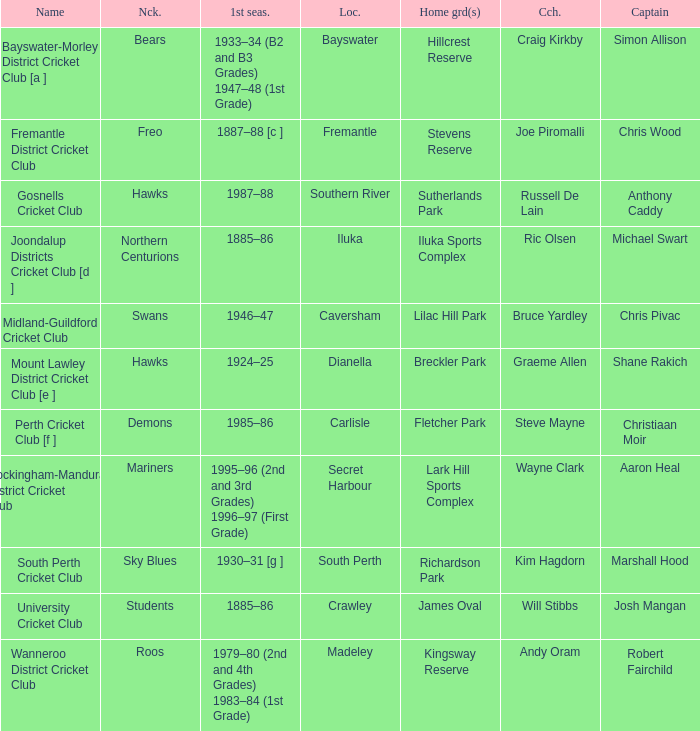What is the code nickname where Steve Mayne is the coach? Demons. Can you parse all the data within this table? {'header': ['Name', 'Nck.', '1st seas.', 'Loc.', 'Home grd(s)', 'Cch.', 'Captain'], 'rows': [['Bayswater-Morley District Cricket Club [a ]', 'Bears', '1933–34 (B2 and B3 Grades) 1947–48 (1st Grade)', 'Bayswater', 'Hillcrest Reserve', 'Craig Kirkby', 'Simon Allison'], ['Fremantle District Cricket Club', 'Freo', '1887–88 [c ]', 'Fremantle', 'Stevens Reserve', 'Joe Piromalli', 'Chris Wood'], ['Gosnells Cricket Club', 'Hawks', '1987–88', 'Southern River', 'Sutherlands Park', 'Russell De Lain', 'Anthony Caddy'], ['Joondalup Districts Cricket Club [d ]', 'Northern Centurions', '1885–86', 'Iluka', 'Iluka Sports Complex', 'Ric Olsen', 'Michael Swart'], ['Midland-Guildford Cricket Club', 'Swans', '1946–47', 'Caversham', 'Lilac Hill Park', 'Bruce Yardley', 'Chris Pivac'], ['Mount Lawley District Cricket Club [e ]', 'Hawks', '1924–25', 'Dianella', 'Breckler Park', 'Graeme Allen', 'Shane Rakich'], ['Perth Cricket Club [f ]', 'Demons', '1985–86', 'Carlisle', 'Fletcher Park', 'Steve Mayne', 'Christiaan Moir'], ['Rockingham-Mandurah District Cricket Club', 'Mariners', '1995–96 (2nd and 3rd Grades) 1996–97 (First Grade)', 'Secret Harbour', 'Lark Hill Sports Complex', 'Wayne Clark', 'Aaron Heal'], ['South Perth Cricket Club', 'Sky Blues', '1930–31 [g ]', 'South Perth', 'Richardson Park', 'Kim Hagdorn', 'Marshall Hood'], ['University Cricket Club', 'Students', '1885–86', 'Crawley', 'James Oval', 'Will Stibbs', 'Josh Mangan'], ['Wanneroo District Cricket Club', 'Roos', '1979–80 (2nd and 4th Grades) 1983–84 (1st Grade)', 'Madeley', 'Kingsway Reserve', 'Andy Oram', 'Robert Fairchild']]} 